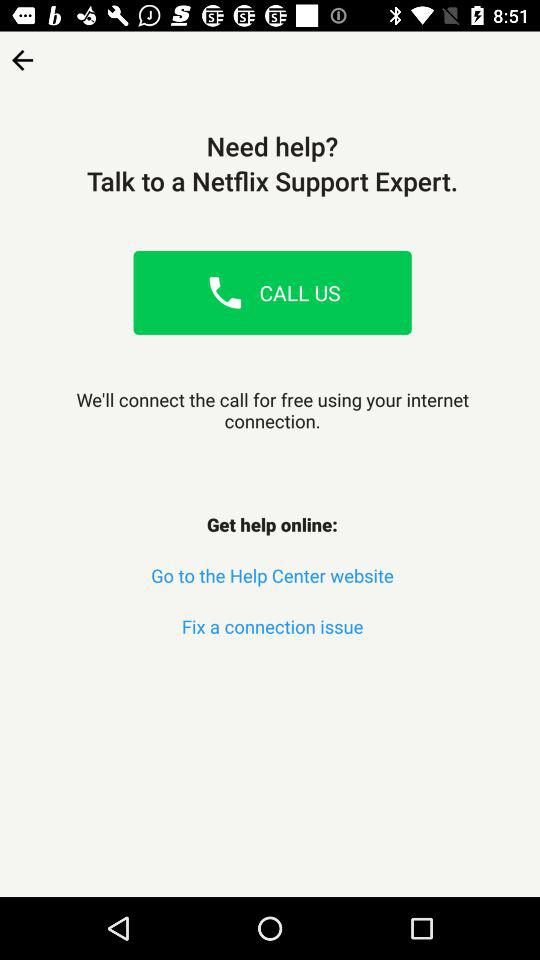What is the application name? The application name is "Netflix". 